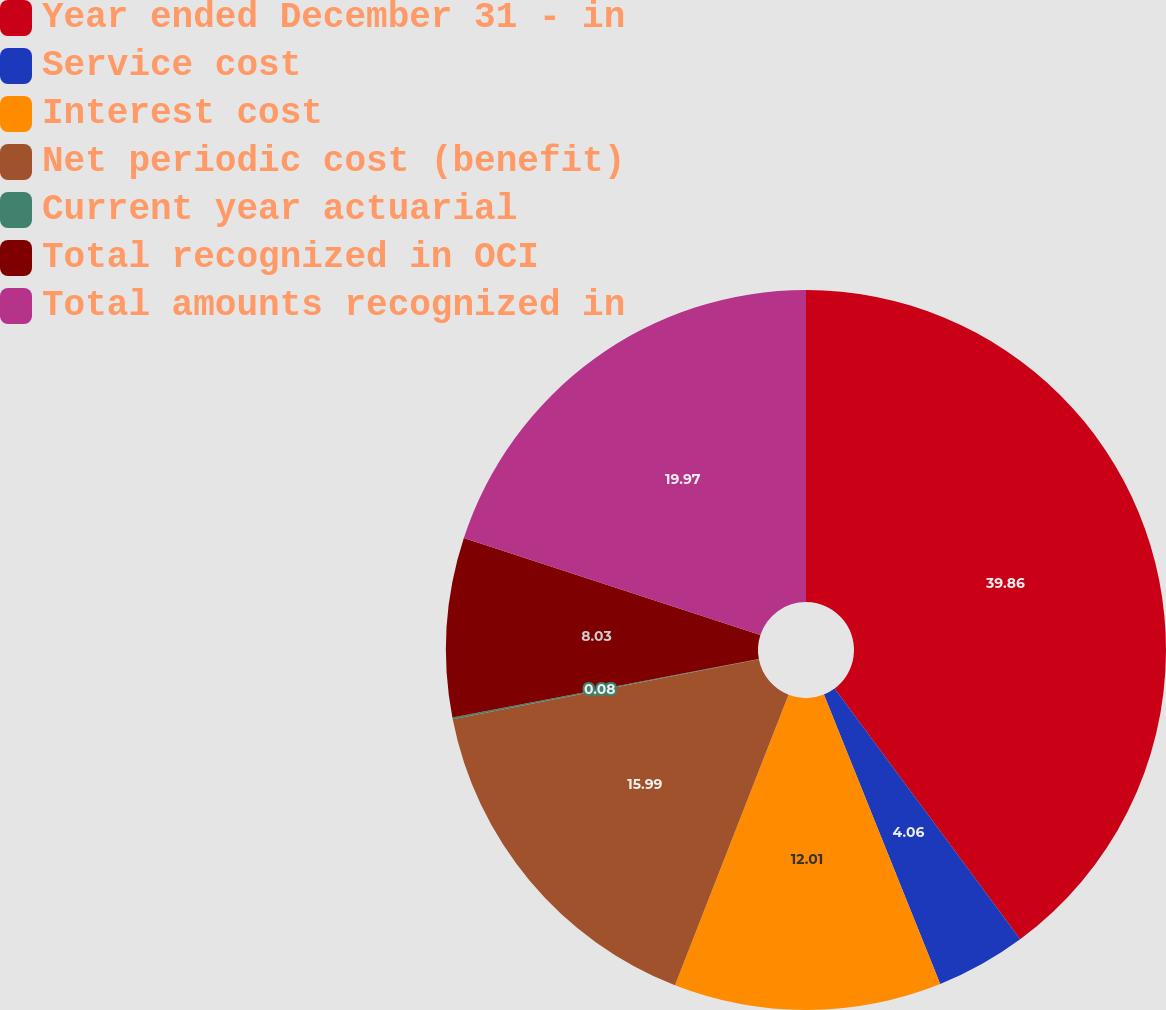Convert chart. <chart><loc_0><loc_0><loc_500><loc_500><pie_chart><fcel>Year ended December 31 - in<fcel>Service cost<fcel>Interest cost<fcel>Net periodic cost (benefit)<fcel>Current year actuarial<fcel>Total recognized in OCI<fcel>Total amounts recognized in<nl><fcel>39.86%<fcel>4.06%<fcel>12.01%<fcel>15.99%<fcel>0.08%<fcel>8.03%<fcel>19.97%<nl></chart> 